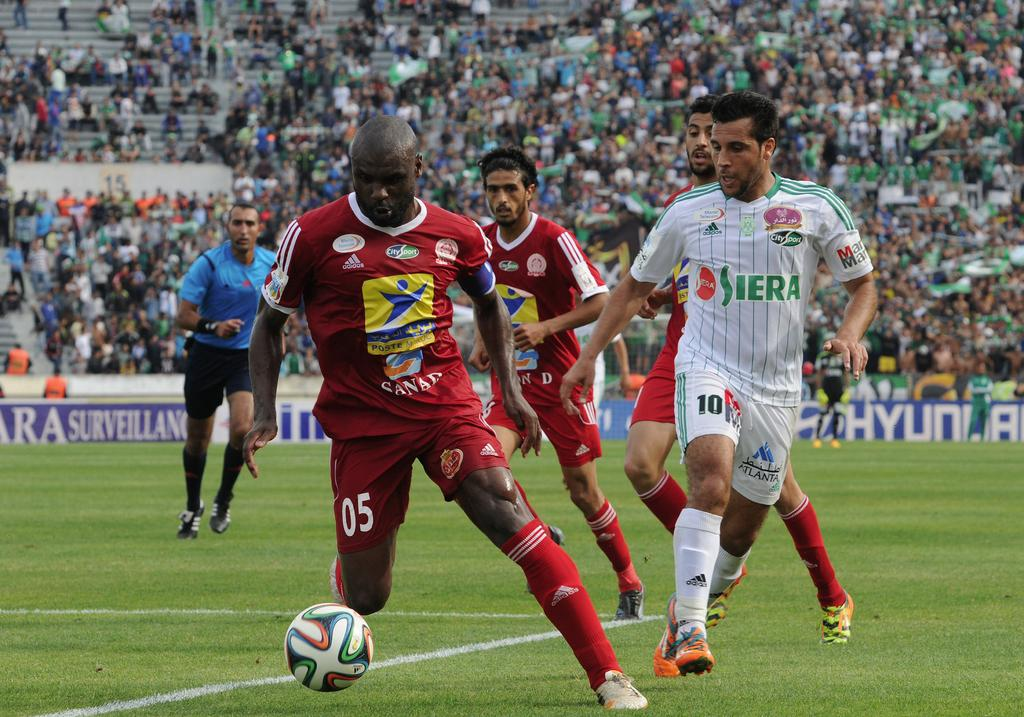<image>
Present a compact description of the photo's key features. Player number 05 has control of the soccer ball, as other players and a ref run to keep up. 